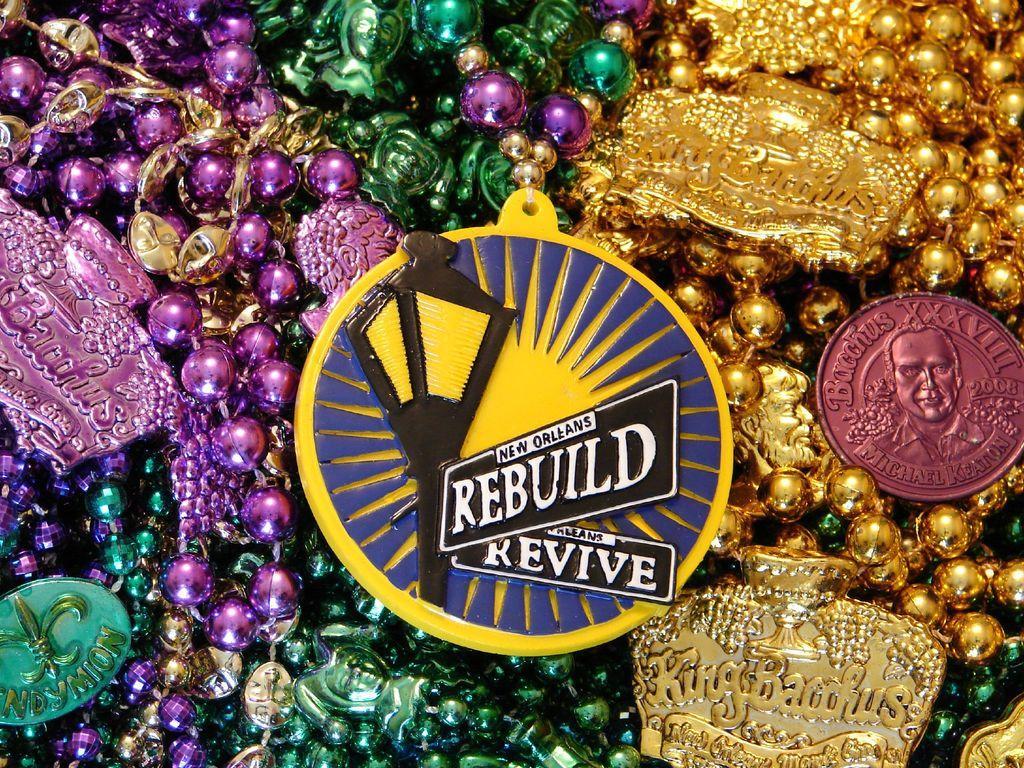Could you give a brief overview of what you see in this image? In this image I can see number of colourful things and on the few things I can see something is written. 